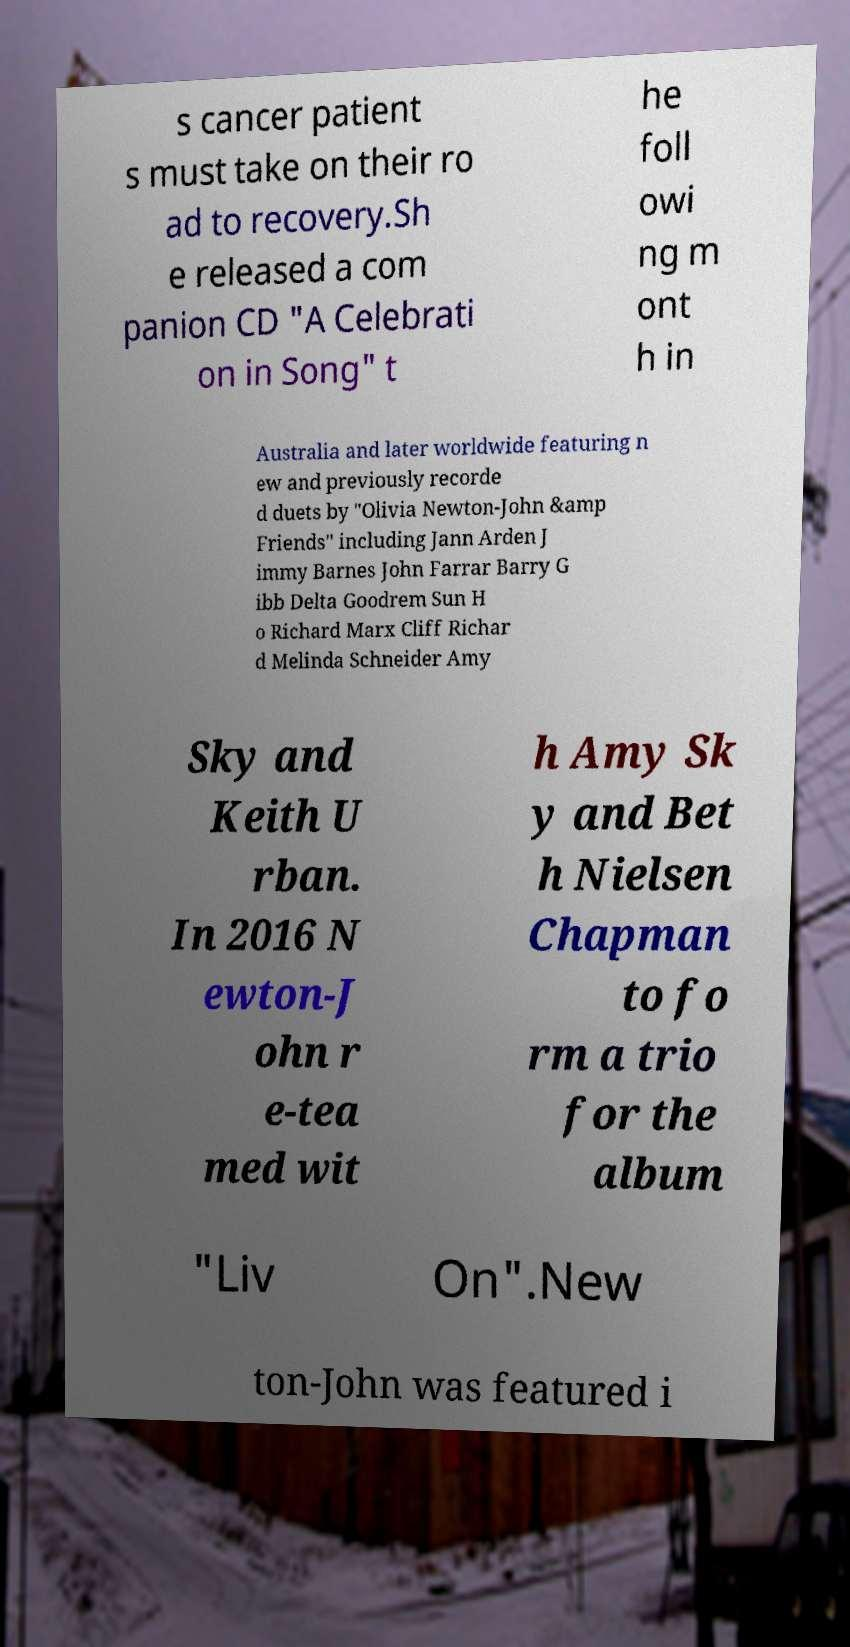Please identify and transcribe the text found in this image. s cancer patient s must take on their ro ad to recovery.Sh e released a com panion CD "A Celebrati on in Song" t he foll owi ng m ont h in Australia and later worldwide featuring n ew and previously recorde d duets by "Olivia Newton-John &amp Friends" including Jann Arden J immy Barnes John Farrar Barry G ibb Delta Goodrem Sun H o Richard Marx Cliff Richar d Melinda Schneider Amy Sky and Keith U rban. In 2016 N ewton-J ohn r e-tea med wit h Amy Sk y and Bet h Nielsen Chapman to fo rm a trio for the album "Liv On".New ton-John was featured i 